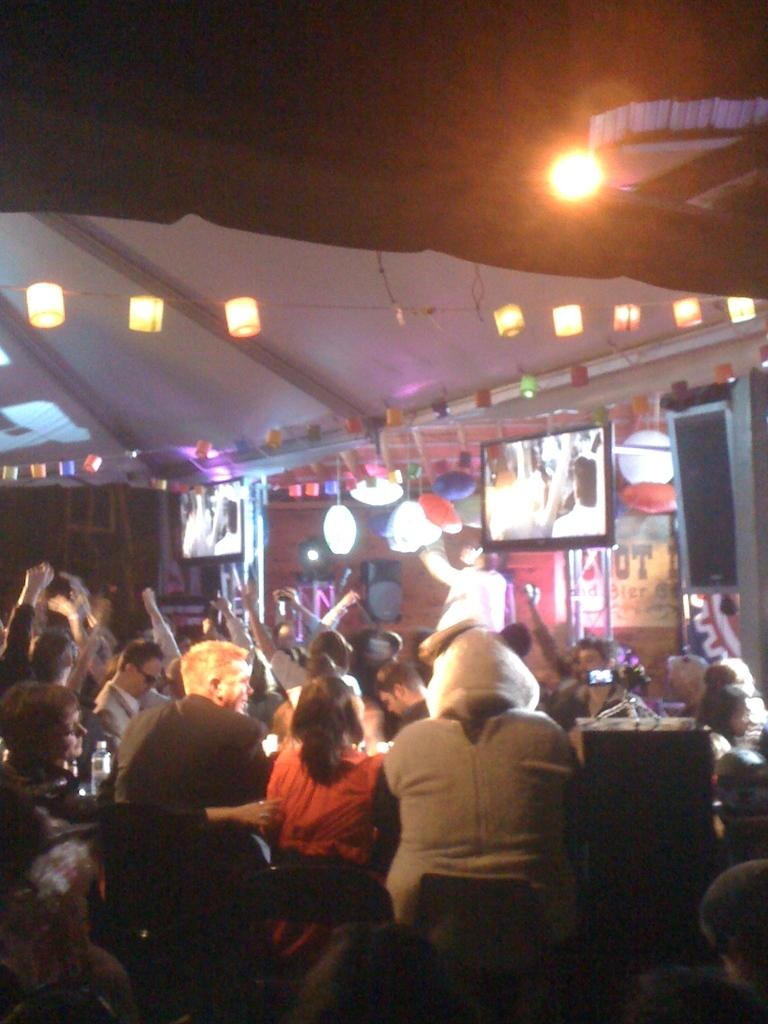What is happening in the image involving people? There are people standing in the image, which suggests they might be attending an event or gathering. Can you describe the person on the stage? There is a person on a stage, which implies they might be a performer or speaker. What electronic devices are present in the image? There are televisions in the image, which could be used for displaying information or entertainment. What is used for amplifying sound in the image? There is a speaker in the image, which is used for amplifying sound. What can be seen providing illumination in the image? There are lights visible in the image, which suggests the event or gathering is taking place in a well-lit area. What type of quince is being used to prepare a dish in the image? There is no quince present in the image, nor is there any indication of food preparation. Is there an oven visible in the image? No, there is no oven present in the image. 